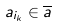Convert formula to latex. <formula><loc_0><loc_0><loc_500><loc_500>a _ { i _ { k } } \in \overline { a }</formula> 